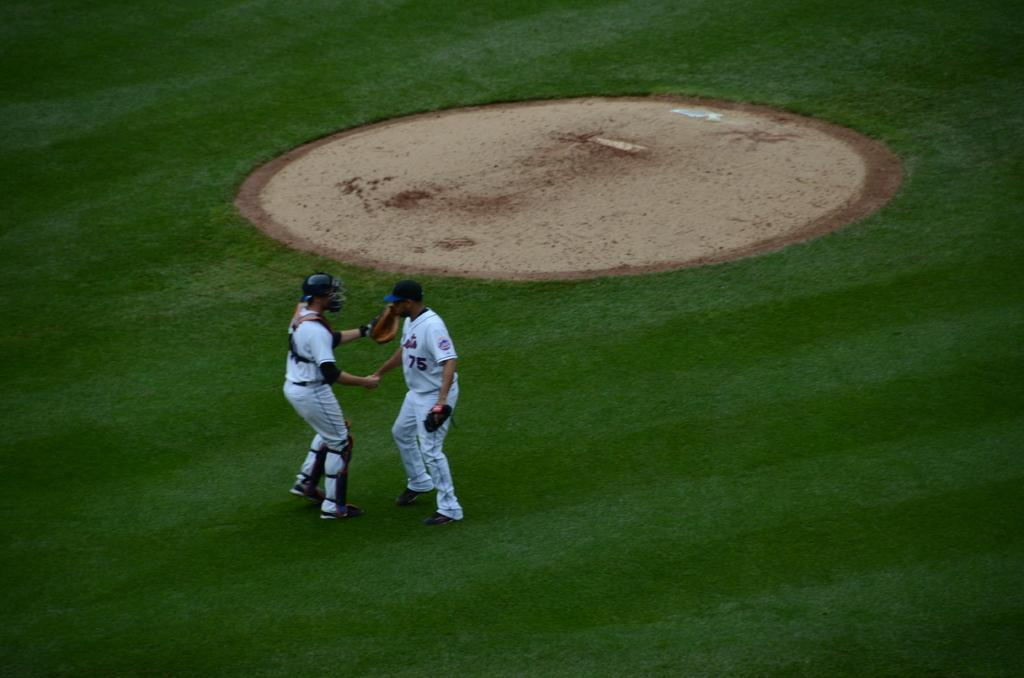How many people are in the image? There are two men standing in the image. What are the men wearing? Both men are wearing clothes and shoes. Can you describe any accessories the men are wearing? One person is wearing a glove, and another person is wearing a helmet. One person is also wearing a cap. What type of terrain is visible in the image? There is grass and sand visible in the image. What type of advertisement can be seen on the helmet in the image? There is no advertisement visible on the helmet in the image. Can you tell me how many pins are attached to the cap in the image? There is no mention of pins in the image, and no pins are visible on the cap. 